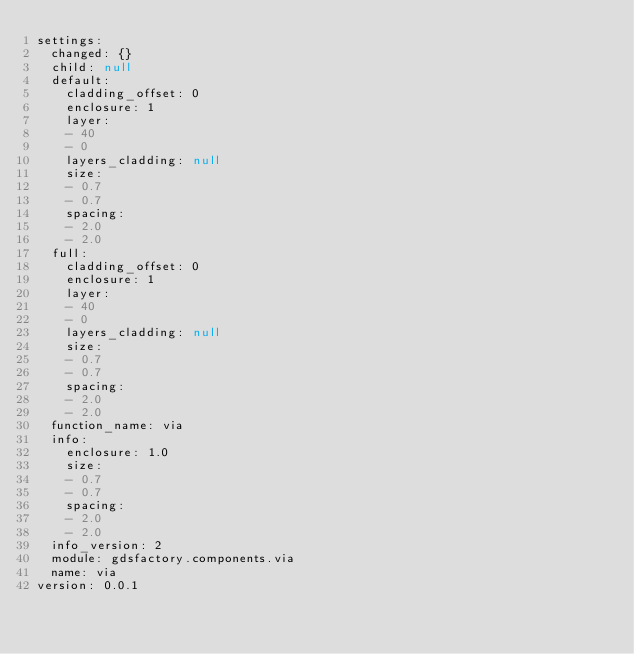<code> <loc_0><loc_0><loc_500><loc_500><_YAML_>settings:
  changed: {}
  child: null
  default:
    cladding_offset: 0
    enclosure: 1
    layer:
    - 40
    - 0
    layers_cladding: null
    size:
    - 0.7
    - 0.7
    spacing:
    - 2.0
    - 2.0
  full:
    cladding_offset: 0
    enclosure: 1
    layer:
    - 40
    - 0
    layers_cladding: null
    size:
    - 0.7
    - 0.7
    spacing:
    - 2.0
    - 2.0
  function_name: via
  info:
    enclosure: 1.0
    size:
    - 0.7
    - 0.7
    spacing:
    - 2.0
    - 2.0
  info_version: 2
  module: gdsfactory.components.via
  name: via
version: 0.0.1
</code> 